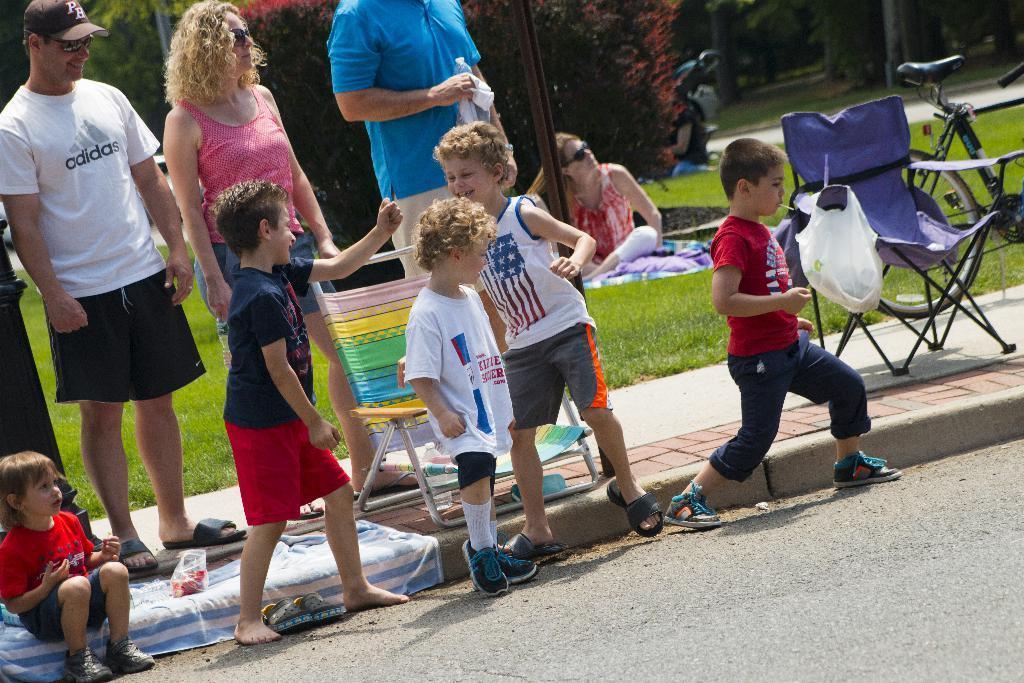Could you give a brief overview of what you see in this image? In this picture we can see few chairs and group of people, few are sitting on the grass and few are standing, on the right side of the image we can see a bicycle, in the background we can find few trees. 